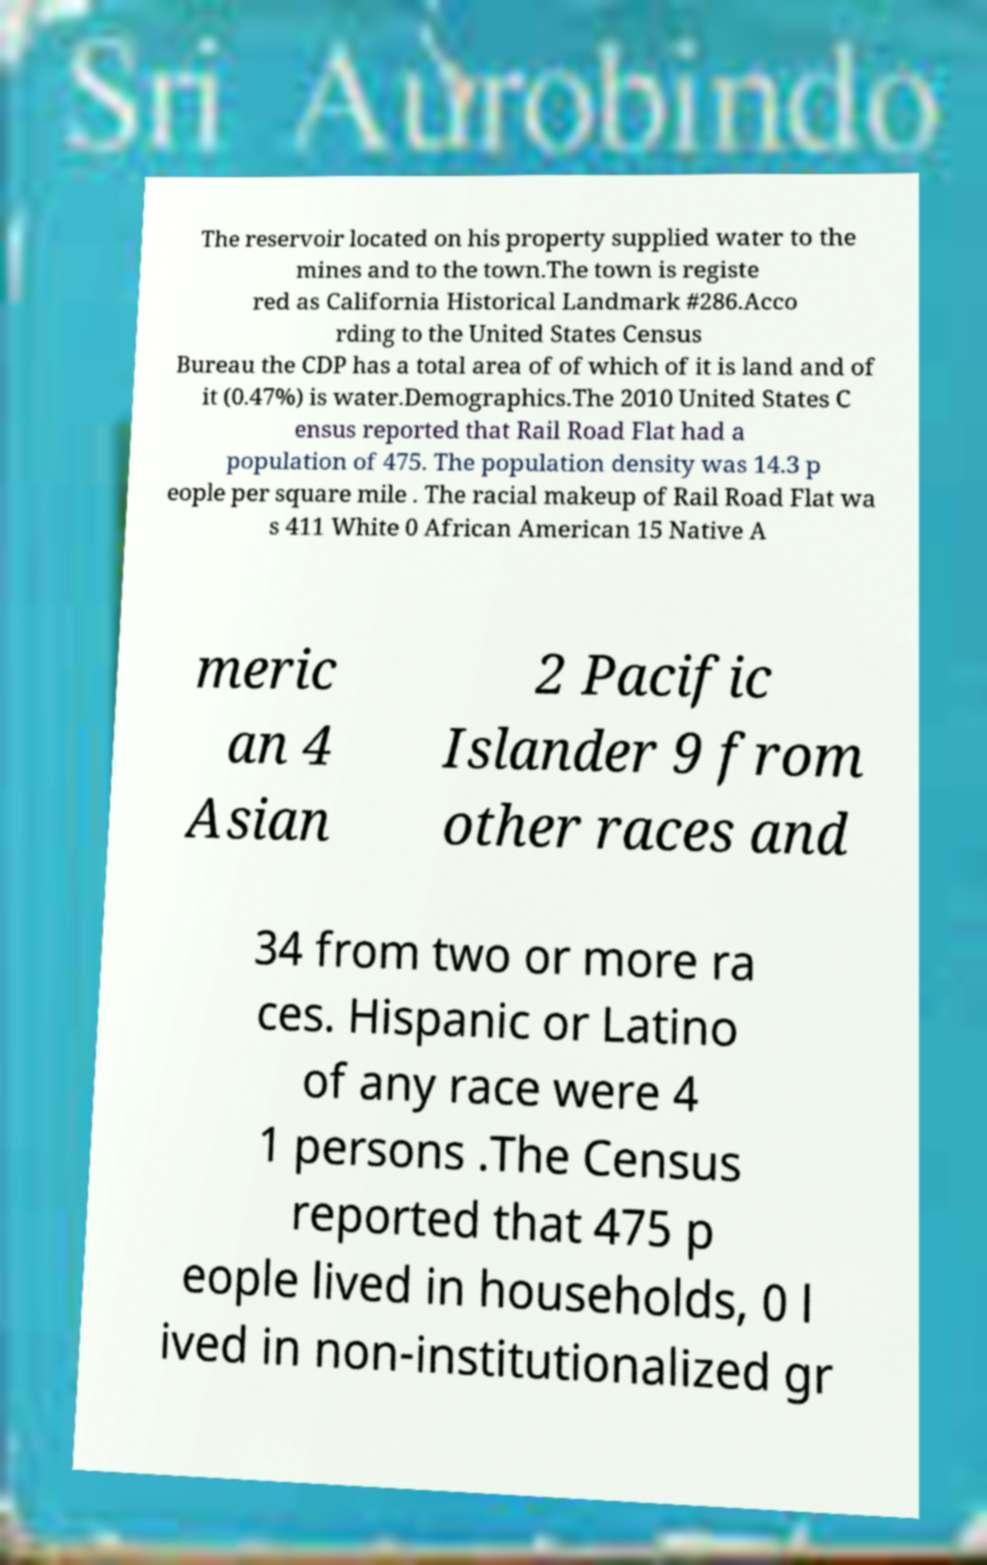Can you accurately transcribe the text from the provided image for me? The reservoir located on his property supplied water to the mines and to the town.The town is registe red as California Historical Landmark #286.Acco rding to the United States Census Bureau the CDP has a total area of of which of it is land and of it (0.47%) is water.Demographics.The 2010 United States C ensus reported that Rail Road Flat had a population of 475. The population density was 14.3 p eople per square mile . The racial makeup of Rail Road Flat wa s 411 White 0 African American 15 Native A meric an 4 Asian 2 Pacific Islander 9 from other races and 34 from two or more ra ces. Hispanic or Latino of any race were 4 1 persons .The Census reported that 475 p eople lived in households, 0 l ived in non-institutionalized gr 